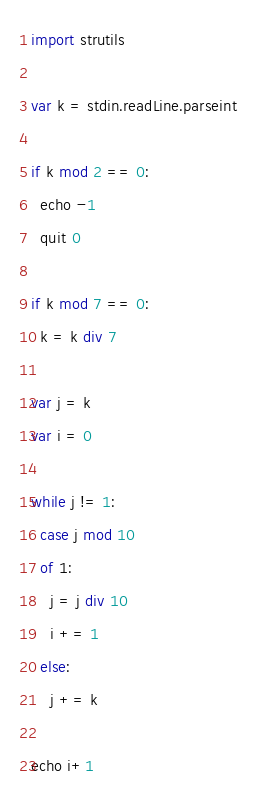Convert code to text. <code><loc_0><loc_0><loc_500><loc_500><_Nim_>import strutils

var k = stdin.readLine.parseint

if k mod 2 == 0:
  echo -1
  quit 0

if k mod 7 == 0:
  k = k div 7

var j = k
var i = 0

while j != 1:
  case j mod 10
  of 1:
    j = j div 10
    i += 1
  else:
    j += k

echo i+1
</code> 